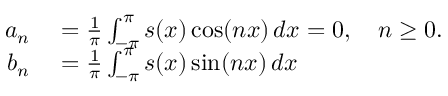Convert formula to latex. <formula><loc_0><loc_0><loc_500><loc_500>\begin{array} { r l } { a _ { n } } & = { \frac { 1 } { \pi } } \int _ { - \pi } ^ { \pi } s ( x ) \cos ( n x ) \, d x = 0 , \quad n \geq 0 . } \\ { b _ { n } } & = { \frac { 1 } { \pi } } \int _ { - \pi } ^ { \pi } s ( x ) \sin ( n x ) \, d x } \end{array}</formula> 